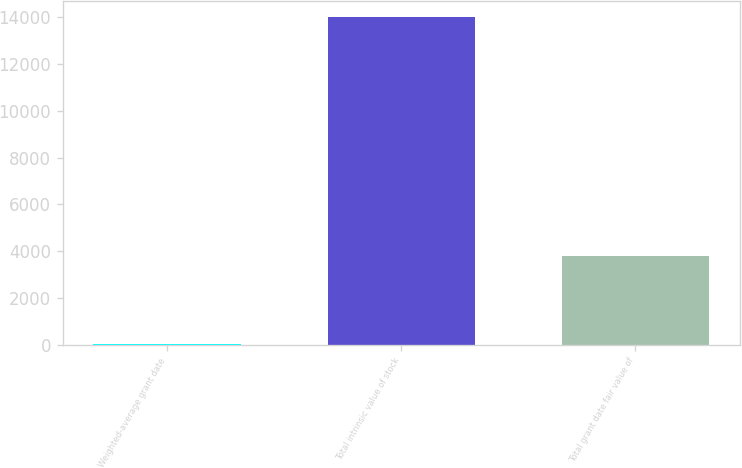Convert chart. <chart><loc_0><loc_0><loc_500><loc_500><bar_chart><fcel>Weighted-average grant date<fcel>Total intrinsic value of stock<fcel>Total grant date fair value of<nl><fcel>8.23<fcel>14001<fcel>3796<nl></chart> 